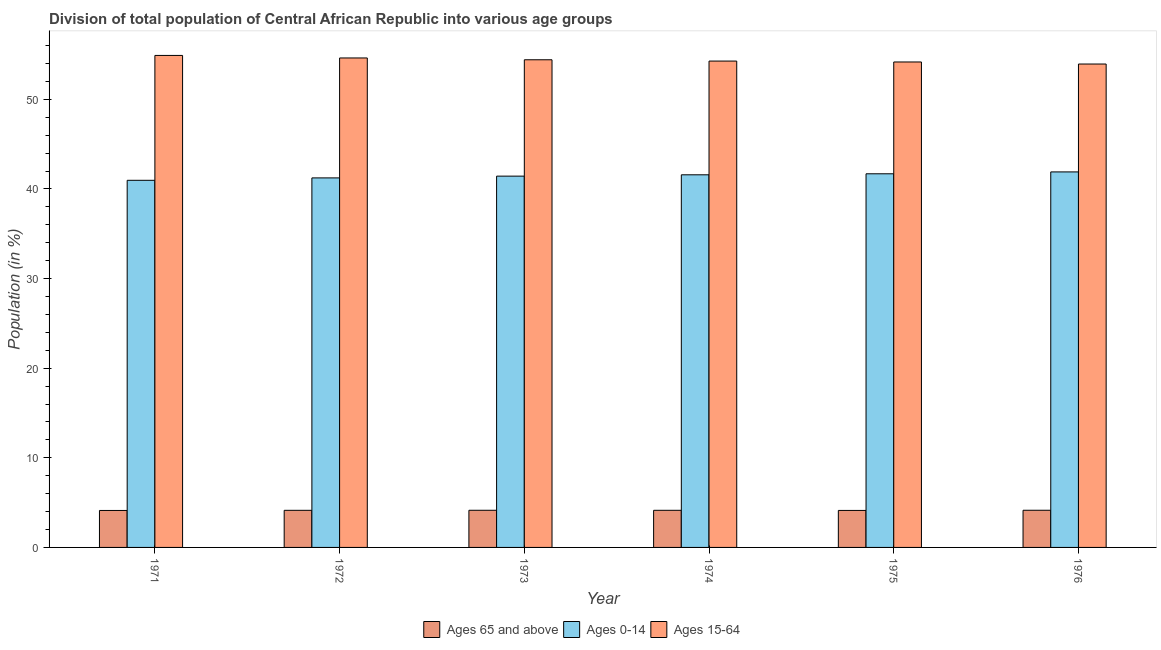How many groups of bars are there?
Offer a terse response. 6. Are the number of bars on each tick of the X-axis equal?
Keep it short and to the point. Yes. In how many cases, is the number of bars for a given year not equal to the number of legend labels?
Keep it short and to the point. 0. What is the percentage of population within the age-group 15-64 in 1975?
Make the answer very short. 54.17. Across all years, what is the maximum percentage of population within the age-group 0-14?
Ensure brevity in your answer.  41.91. Across all years, what is the minimum percentage of population within the age-group 0-14?
Give a very brief answer. 40.97. In which year was the percentage of population within the age-group of 65 and above maximum?
Your response must be concise. 1976. In which year was the percentage of population within the age-group of 65 and above minimum?
Provide a short and direct response. 1971. What is the total percentage of population within the age-group 15-64 in the graph?
Make the answer very short. 326.34. What is the difference between the percentage of population within the age-group 0-14 in 1972 and that in 1976?
Ensure brevity in your answer.  -0.67. What is the difference between the percentage of population within the age-group 15-64 in 1974 and the percentage of population within the age-group 0-14 in 1972?
Provide a succinct answer. -0.35. What is the average percentage of population within the age-group 0-14 per year?
Make the answer very short. 41.47. In how many years, is the percentage of population within the age-group of 65 and above greater than 2 %?
Offer a terse response. 6. What is the ratio of the percentage of population within the age-group 0-14 in 1972 to that in 1973?
Provide a succinct answer. 1. Is the percentage of population within the age-group of 65 and above in 1973 less than that in 1976?
Your answer should be compact. Yes. Is the difference between the percentage of population within the age-group 15-64 in 1972 and 1976 greater than the difference between the percentage of population within the age-group of 65 and above in 1972 and 1976?
Give a very brief answer. No. What is the difference between the highest and the second highest percentage of population within the age-group 15-64?
Ensure brevity in your answer.  0.28. What is the difference between the highest and the lowest percentage of population within the age-group of 65 and above?
Make the answer very short. 0.02. What does the 2nd bar from the left in 1973 represents?
Offer a terse response. Ages 0-14. What does the 3rd bar from the right in 1975 represents?
Your answer should be compact. Ages 65 and above. How many years are there in the graph?
Provide a short and direct response. 6. Are the values on the major ticks of Y-axis written in scientific E-notation?
Offer a terse response. No. Does the graph contain any zero values?
Ensure brevity in your answer.  No. What is the title of the graph?
Provide a short and direct response. Division of total population of Central African Republic into various age groups
. What is the label or title of the X-axis?
Ensure brevity in your answer.  Year. What is the label or title of the Y-axis?
Make the answer very short. Population (in %). What is the Population (in %) of Ages 65 and above in 1971?
Offer a very short reply. 4.12. What is the Population (in %) of Ages 0-14 in 1971?
Offer a terse response. 40.97. What is the Population (in %) in Ages 15-64 in 1971?
Ensure brevity in your answer.  54.91. What is the Population (in %) in Ages 65 and above in 1972?
Offer a terse response. 4.14. What is the Population (in %) of Ages 0-14 in 1972?
Ensure brevity in your answer.  41.24. What is the Population (in %) of Ages 15-64 in 1972?
Provide a succinct answer. 54.62. What is the Population (in %) of Ages 65 and above in 1973?
Offer a very short reply. 4.15. What is the Population (in %) in Ages 0-14 in 1973?
Keep it short and to the point. 41.43. What is the Population (in %) of Ages 15-64 in 1973?
Provide a short and direct response. 54.42. What is the Population (in %) in Ages 65 and above in 1974?
Make the answer very short. 4.14. What is the Population (in %) of Ages 0-14 in 1974?
Provide a succinct answer. 41.58. What is the Population (in %) in Ages 15-64 in 1974?
Your answer should be compact. 54.28. What is the Population (in %) in Ages 65 and above in 1975?
Offer a very short reply. 4.13. What is the Population (in %) of Ages 0-14 in 1975?
Your answer should be compact. 41.7. What is the Population (in %) of Ages 15-64 in 1975?
Keep it short and to the point. 54.17. What is the Population (in %) in Ages 65 and above in 1976?
Provide a short and direct response. 4.15. What is the Population (in %) of Ages 0-14 in 1976?
Provide a short and direct response. 41.91. What is the Population (in %) in Ages 15-64 in 1976?
Give a very brief answer. 53.95. Across all years, what is the maximum Population (in %) in Ages 65 and above?
Offer a terse response. 4.15. Across all years, what is the maximum Population (in %) of Ages 0-14?
Your answer should be very brief. 41.91. Across all years, what is the maximum Population (in %) of Ages 15-64?
Provide a succinct answer. 54.91. Across all years, what is the minimum Population (in %) in Ages 65 and above?
Provide a succinct answer. 4.12. Across all years, what is the minimum Population (in %) in Ages 0-14?
Your answer should be very brief. 40.97. Across all years, what is the minimum Population (in %) in Ages 15-64?
Offer a very short reply. 53.95. What is the total Population (in %) in Ages 65 and above in the graph?
Make the answer very short. 24.83. What is the total Population (in %) in Ages 0-14 in the graph?
Keep it short and to the point. 248.83. What is the total Population (in %) of Ages 15-64 in the graph?
Make the answer very short. 326.34. What is the difference between the Population (in %) of Ages 65 and above in 1971 and that in 1972?
Your answer should be very brief. -0.02. What is the difference between the Population (in %) of Ages 0-14 in 1971 and that in 1972?
Give a very brief answer. -0.27. What is the difference between the Population (in %) in Ages 15-64 in 1971 and that in 1972?
Give a very brief answer. 0.28. What is the difference between the Population (in %) in Ages 65 and above in 1971 and that in 1973?
Provide a succinct answer. -0.02. What is the difference between the Population (in %) in Ages 0-14 in 1971 and that in 1973?
Your response must be concise. -0.46. What is the difference between the Population (in %) of Ages 15-64 in 1971 and that in 1973?
Offer a terse response. 0.49. What is the difference between the Population (in %) in Ages 65 and above in 1971 and that in 1974?
Provide a succinct answer. -0.02. What is the difference between the Population (in %) of Ages 0-14 in 1971 and that in 1974?
Provide a succinct answer. -0.61. What is the difference between the Population (in %) in Ages 15-64 in 1971 and that in 1974?
Provide a succinct answer. 0.63. What is the difference between the Population (in %) of Ages 65 and above in 1971 and that in 1975?
Your answer should be very brief. -0. What is the difference between the Population (in %) of Ages 0-14 in 1971 and that in 1975?
Provide a short and direct response. -0.73. What is the difference between the Population (in %) of Ages 15-64 in 1971 and that in 1975?
Offer a terse response. 0.73. What is the difference between the Population (in %) in Ages 65 and above in 1971 and that in 1976?
Offer a terse response. -0.02. What is the difference between the Population (in %) in Ages 0-14 in 1971 and that in 1976?
Offer a terse response. -0.94. What is the difference between the Population (in %) of Ages 15-64 in 1971 and that in 1976?
Offer a terse response. 0.96. What is the difference between the Population (in %) in Ages 65 and above in 1972 and that in 1973?
Give a very brief answer. -0.01. What is the difference between the Population (in %) in Ages 0-14 in 1972 and that in 1973?
Provide a succinct answer. -0.2. What is the difference between the Population (in %) of Ages 15-64 in 1972 and that in 1973?
Make the answer very short. 0.2. What is the difference between the Population (in %) of Ages 65 and above in 1972 and that in 1974?
Ensure brevity in your answer.  -0. What is the difference between the Population (in %) of Ages 0-14 in 1972 and that in 1974?
Make the answer very short. -0.35. What is the difference between the Population (in %) of Ages 15-64 in 1972 and that in 1974?
Give a very brief answer. 0.35. What is the difference between the Population (in %) in Ages 65 and above in 1972 and that in 1975?
Provide a short and direct response. 0.01. What is the difference between the Population (in %) of Ages 0-14 in 1972 and that in 1975?
Offer a very short reply. -0.46. What is the difference between the Population (in %) of Ages 15-64 in 1972 and that in 1975?
Your answer should be very brief. 0.45. What is the difference between the Population (in %) of Ages 65 and above in 1972 and that in 1976?
Your response must be concise. -0.01. What is the difference between the Population (in %) of Ages 0-14 in 1972 and that in 1976?
Your answer should be compact. -0.67. What is the difference between the Population (in %) of Ages 15-64 in 1972 and that in 1976?
Your answer should be very brief. 0.68. What is the difference between the Population (in %) in Ages 65 and above in 1973 and that in 1974?
Provide a succinct answer. 0. What is the difference between the Population (in %) of Ages 0-14 in 1973 and that in 1974?
Ensure brevity in your answer.  -0.15. What is the difference between the Population (in %) of Ages 15-64 in 1973 and that in 1974?
Keep it short and to the point. 0.14. What is the difference between the Population (in %) in Ages 65 and above in 1973 and that in 1975?
Ensure brevity in your answer.  0.02. What is the difference between the Population (in %) in Ages 0-14 in 1973 and that in 1975?
Keep it short and to the point. -0.26. What is the difference between the Population (in %) of Ages 15-64 in 1973 and that in 1975?
Ensure brevity in your answer.  0.24. What is the difference between the Population (in %) of Ages 65 and above in 1973 and that in 1976?
Provide a succinct answer. -0. What is the difference between the Population (in %) of Ages 0-14 in 1973 and that in 1976?
Offer a very short reply. -0.47. What is the difference between the Population (in %) in Ages 15-64 in 1973 and that in 1976?
Give a very brief answer. 0.47. What is the difference between the Population (in %) in Ages 65 and above in 1974 and that in 1975?
Make the answer very short. 0.01. What is the difference between the Population (in %) in Ages 0-14 in 1974 and that in 1975?
Give a very brief answer. -0.11. What is the difference between the Population (in %) of Ages 15-64 in 1974 and that in 1975?
Your answer should be very brief. 0.1. What is the difference between the Population (in %) of Ages 65 and above in 1974 and that in 1976?
Offer a very short reply. -0.01. What is the difference between the Population (in %) in Ages 0-14 in 1974 and that in 1976?
Keep it short and to the point. -0.32. What is the difference between the Population (in %) in Ages 15-64 in 1974 and that in 1976?
Give a very brief answer. 0.33. What is the difference between the Population (in %) in Ages 65 and above in 1975 and that in 1976?
Your response must be concise. -0.02. What is the difference between the Population (in %) of Ages 0-14 in 1975 and that in 1976?
Make the answer very short. -0.21. What is the difference between the Population (in %) of Ages 15-64 in 1975 and that in 1976?
Offer a terse response. 0.23. What is the difference between the Population (in %) of Ages 65 and above in 1971 and the Population (in %) of Ages 0-14 in 1972?
Your answer should be compact. -37.11. What is the difference between the Population (in %) of Ages 65 and above in 1971 and the Population (in %) of Ages 15-64 in 1972?
Your answer should be very brief. -50.5. What is the difference between the Population (in %) of Ages 0-14 in 1971 and the Population (in %) of Ages 15-64 in 1972?
Ensure brevity in your answer.  -13.65. What is the difference between the Population (in %) in Ages 65 and above in 1971 and the Population (in %) in Ages 0-14 in 1973?
Your response must be concise. -37.31. What is the difference between the Population (in %) in Ages 65 and above in 1971 and the Population (in %) in Ages 15-64 in 1973?
Provide a succinct answer. -50.29. What is the difference between the Population (in %) of Ages 0-14 in 1971 and the Population (in %) of Ages 15-64 in 1973?
Offer a terse response. -13.45. What is the difference between the Population (in %) of Ages 65 and above in 1971 and the Population (in %) of Ages 0-14 in 1974?
Provide a succinct answer. -37.46. What is the difference between the Population (in %) of Ages 65 and above in 1971 and the Population (in %) of Ages 15-64 in 1974?
Keep it short and to the point. -50.15. What is the difference between the Population (in %) in Ages 0-14 in 1971 and the Population (in %) in Ages 15-64 in 1974?
Provide a short and direct response. -13.31. What is the difference between the Population (in %) of Ages 65 and above in 1971 and the Population (in %) of Ages 0-14 in 1975?
Provide a short and direct response. -37.57. What is the difference between the Population (in %) in Ages 65 and above in 1971 and the Population (in %) in Ages 15-64 in 1975?
Your answer should be compact. -50.05. What is the difference between the Population (in %) in Ages 0-14 in 1971 and the Population (in %) in Ages 15-64 in 1975?
Ensure brevity in your answer.  -13.21. What is the difference between the Population (in %) of Ages 65 and above in 1971 and the Population (in %) of Ages 0-14 in 1976?
Offer a very short reply. -37.78. What is the difference between the Population (in %) in Ages 65 and above in 1971 and the Population (in %) in Ages 15-64 in 1976?
Your answer should be very brief. -49.82. What is the difference between the Population (in %) of Ages 0-14 in 1971 and the Population (in %) of Ages 15-64 in 1976?
Provide a succinct answer. -12.98. What is the difference between the Population (in %) in Ages 65 and above in 1972 and the Population (in %) in Ages 0-14 in 1973?
Your answer should be compact. -37.29. What is the difference between the Population (in %) of Ages 65 and above in 1972 and the Population (in %) of Ages 15-64 in 1973?
Keep it short and to the point. -50.28. What is the difference between the Population (in %) of Ages 0-14 in 1972 and the Population (in %) of Ages 15-64 in 1973?
Keep it short and to the point. -13.18. What is the difference between the Population (in %) of Ages 65 and above in 1972 and the Population (in %) of Ages 0-14 in 1974?
Your answer should be compact. -37.44. What is the difference between the Population (in %) in Ages 65 and above in 1972 and the Population (in %) in Ages 15-64 in 1974?
Provide a succinct answer. -50.13. What is the difference between the Population (in %) of Ages 0-14 in 1972 and the Population (in %) of Ages 15-64 in 1974?
Provide a short and direct response. -13.04. What is the difference between the Population (in %) in Ages 65 and above in 1972 and the Population (in %) in Ages 0-14 in 1975?
Your answer should be compact. -37.56. What is the difference between the Population (in %) in Ages 65 and above in 1972 and the Population (in %) in Ages 15-64 in 1975?
Ensure brevity in your answer.  -50.03. What is the difference between the Population (in %) of Ages 0-14 in 1972 and the Population (in %) of Ages 15-64 in 1975?
Provide a short and direct response. -12.94. What is the difference between the Population (in %) in Ages 65 and above in 1972 and the Population (in %) in Ages 0-14 in 1976?
Your response must be concise. -37.77. What is the difference between the Population (in %) in Ages 65 and above in 1972 and the Population (in %) in Ages 15-64 in 1976?
Offer a terse response. -49.81. What is the difference between the Population (in %) of Ages 0-14 in 1972 and the Population (in %) of Ages 15-64 in 1976?
Keep it short and to the point. -12.71. What is the difference between the Population (in %) of Ages 65 and above in 1973 and the Population (in %) of Ages 0-14 in 1974?
Ensure brevity in your answer.  -37.44. What is the difference between the Population (in %) of Ages 65 and above in 1973 and the Population (in %) of Ages 15-64 in 1974?
Your answer should be compact. -50.13. What is the difference between the Population (in %) in Ages 0-14 in 1973 and the Population (in %) in Ages 15-64 in 1974?
Provide a succinct answer. -12.84. What is the difference between the Population (in %) of Ages 65 and above in 1973 and the Population (in %) of Ages 0-14 in 1975?
Your answer should be compact. -37.55. What is the difference between the Population (in %) in Ages 65 and above in 1973 and the Population (in %) in Ages 15-64 in 1975?
Your answer should be very brief. -50.03. What is the difference between the Population (in %) in Ages 0-14 in 1973 and the Population (in %) in Ages 15-64 in 1975?
Keep it short and to the point. -12.74. What is the difference between the Population (in %) in Ages 65 and above in 1973 and the Population (in %) in Ages 0-14 in 1976?
Your answer should be compact. -37.76. What is the difference between the Population (in %) in Ages 65 and above in 1973 and the Population (in %) in Ages 15-64 in 1976?
Ensure brevity in your answer.  -49.8. What is the difference between the Population (in %) in Ages 0-14 in 1973 and the Population (in %) in Ages 15-64 in 1976?
Give a very brief answer. -12.51. What is the difference between the Population (in %) in Ages 65 and above in 1974 and the Population (in %) in Ages 0-14 in 1975?
Make the answer very short. -37.56. What is the difference between the Population (in %) in Ages 65 and above in 1974 and the Population (in %) in Ages 15-64 in 1975?
Provide a succinct answer. -50.03. What is the difference between the Population (in %) in Ages 0-14 in 1974 and the Population (in %) in Ages 15-64 in 1975?
Offer a very short reply. -12.59. What is the difference between the Population (in %) in Ages 65 and above in 1974 and the Population (in %) in Ages 0-14 in 1976?
Ensure brevity in your answer.  -37.76. What is the difference between the Population (in %) of Ages 65 and above in 1974 and the Population (in %) of Ages 15-64 in 1976?
Ensure brevity in your answer.  -49.8. What is the difference between the Population (in %) of Ages 0-14 in 1974 and the Population (in %) of Ages 15-64 in 1976?
Provide a succinct answer. -12.36. What is the difference between the Population (in %) of Ages 65 and above in 1975 and the Population (in %) of Ages 0-14 in 1976?
Provide a short and direct response. -37.78. What is the difference between the Population (in %) in Ages 65 and above in 1975 and the Population (in %) in Ages 15-64 in 1976?
Your answer should be very brief. -49.82. What is the difference between the Population (in %) in Ages 0-14 in 1975 and the Population (in %) in Ages 15-64 in 1976?
Your answer should be very brief. -12.25. What is the average Population (in %) in Ages 65 and above per year?
Provide a succinct answer. 4.14. What is the average Population (in %) in Ages 0-14 per year?
Give a very brief answer. 41.47. What is the average Population (in %) of Ages 15-64 per year?
Provide a succinct answer. 54.39. In the year 1971, what is the difference between the Population (in %) of Ages 65 and above and Population (in %) of Ages 0-14?
Your answer should be compact. -36.84. In the year 1971, what is the difference between the Population (in %) of Ages 65 and above and Population (in %) of Ages 15-64?
Provide a short and direct response. -50.78. In the year 1971, what is the difference between the Population (in %) of Ages 0-14 and Population (in %) of Ages 15-64?
Your response must be concise. -13.94. In the year 1972, what is the difference between the Population (in %) of Ages 65 and above and Population (in %) of Ages 0-14?
Ensure brevity in your answer.  -37.1. In the year 1972, what is the difference between the Population (in %) of Ages 65 and above and Population (in %) of Ages 15-64?
Offer a very short reply. -50.48. In the year 1972, what is the difference between the Population (in %) of Ages 0-14 and Population (in %) of Ages 15-64?
Keep it short and to the point. -13.38. In the year 1973, what is the difference between the Population (in %) of Ages 65 and above and Population (in %) of Ages 0-14?
Keep it short and to the point. -37.29. In the year 1973, what is the difference between the Population (in %) of Ages 65 and above and Population (in %) of Ages 15-64?
Your response must be concise. -50.27. In the year 1973, what is the difference between the Population (in %) in Ages 0-14 and Population (in %) in Ages 15-64?
Offer a very short reply. -12.99. In the year 1974, what is the difference between the Population (in %) in Ages 65 and above and Population (in %) in Ages 0-14?
Provide a succinct answer. -37.44. In the year 1974, what is the difference between the Population (in %) of Ages 65 and above and Population (in %) of Ages 15-64?
Offer a terse response. -50.13. In the year 1974, what is the difference between the Population (in %) of Ages 0-14 and Population (in %) of Ages 15-64?
Your answer should be compact. -12.69. In the year 1975, what is the difference between the Population (in %) of Ages 65 and above and Population (in %) of Ages 0-14?
Keep it short and to the point. -37.57. In the year 1975, what is the difference between the Population (in %) of Ages 65 and above and Population (in %) of Ages 15-64?
Offer a terse response. -50.05. In the year 1975, what is the difference between the Population (in %) in Ages 0-14 and Population (in %) in Ages 15-64?
Give a very brief answer. -12.48. In the year 1976, what is the difference between the Population (in %) in Ages 65 and above and Population (in %) in Ages 0-14?
Give a very brief answer. -37.76. In the year 1976, what is the difference between the Population (in %) in Ages 65 and above and Population (in %) in Ages 15-64?
Make the answer very short. -49.8. In the year 1976, what is the difference between the Population (in %) of Ages 0-14 and Population (in %) of Ages 15-64?
Offer a very short reply. -12.04. What is the ratio of the Population (in %) of Ages 65 and above in 1971 to that in 1972?
Your response must be concise. 1. What is the ratio of the Population (in %) in Ages 0-14 in 1971 to that in 1972?
Provide a short and direct response. 0.99. What is the ratio of the Population (in %) of Ages 65 and above in 1971 to that in 1973?
Provide a short and direct response. 0.99. What is the ratio of the Population (in %) in Ages 15-64 in 1971 to that in 1973?
Offer a terse response. 1.01. What is the ratio of the Population (in %) of Ages 0-14 in 1971 to that in 1974?
Keep it short and to the point. 0.99. What is the ratio of the Population (in %) of Ages 15-64 in 1971 to that in 1974?
Ensure brevity in your answer.  1.01. What is the ratio of the Population (in %) in Ages 65 and above in 1971 to that in 1975?
Your answer should be very brief. 1. What is the ratio of the Population (in %) of Ages 0-14 in 1971 to that in 1975?
Provide a succinct answer. 0.98. What is the ratio of the Population (in %) of Ages 15-64 in 1971 to that in 1975?
Keep it short and to the point. 1.01. What is the ratio of the Population (in %) in Ages 0-14 in 1971 to that in 1976?
Provide a succinct answer. 0.98. What is the ratio of the Population (in %) in Ages 15-64 in 1971 to that in 1976?
Provide a succinct answer. 1.02. What is the ratio of the Population (in %) in Ages 0-14 in 1972 to that in 1973?
Your answer should be very brief. 1. What is the ratio of the Population (in %) of Ages 15-64 in 1972 to that in 1973?
Your answer should be compact. 1. What is the ratio of the Population (in %) of Ages 65 and above in 1972 to that in 1974?
Give a very brief answer. 1. What is the ratio of the Population (in %) in Ages 0-14 in 1972 to that in 1974?
Your answer should be very brief. 0.99. What is the ratio of the Population (in %) in Ages 15-64 in 1972 to that in 1974?
Make the answer very short. 1.01. What is the ratio of the Population (in %) of Ages 65 and above in 1972 to that in 1975?
Provide a short and direct response. 1. What is the ratio of the Population (in %) of Ages 15-64 in 1972 to that in 1975?
Your response must be concise. 1.01. What is the ratio of the Population (in %) of Ages 15-64 in 1972 to that in 1976?
Keep it short and to the point. 1.01. What is the ratio of the Population (in %) in Ages 0-14 in 1973 to that in 1974?
Your answer should be compact. 1. What is the ratio of the Population (in %) of Ages 65 and above in 1973 to that in 1975?
Provide a succinct answer. 1. What is the ratio of the Population (in %) in Ages 15-64 in 1973 to that in 1975?
Ensure brevity in your answer.  1. What is the ratio of the Population (in %) in Ages 65 and above in 1973 to that in 1976?
Provide a succinct answer. 1. What is the ratio of the Population (in %) of Ages 0-14 in 1973 to that in 1976?
Give a very brief answer. 0.99. What is the ratio of the Population (in %) of Ages 15-64 in 1973 to that in 1976?
Ensure brevity in your answer.  1.01. What is the ratio of the Population (in %) of Ages 0-14 in 1974 to that in 1975?
Provide a short and direct response. 1. What is the ratio of the Population (in %) of Ages 65 and above in 1974 to that in 1976?
Give a very brief answer. 1. What is the ratio of the Population (in %) of Ages 0-14 in 1974 to that in 1976?
Make the answer very short. 0.99. What is the ratio of the Population (in %) in Ages 15-64 in 1974 to that in 1976?
Your response must be concise. 1.01. What is the ratio of the Population (in %) of Ages 0-14 in 1975 to that in 1976?
Provide a succinct answer. 0.99. What is the ratio of the Population (in %) in Ages 15-64 in 1975 to that in 1976?
Provide a short and direct response. 1. What is the difference between the highest and the second highest Population (in %) in Ages 65 and above?
Provide a succinct answer. 0. What is the difference between the highest and the second highest Population (in %) of Ages 0-14?
Ensure brevity in your answer.  0.21. What is the difference between the highest and the second highest Population (in %) in Ages 15-64?
Ensure brevity in your answer.  0.28. What is the difference between the highest and the lowest Population (in %) in Ages 65 and above?
Offer a very short reply. 0.02. What is the difference between the highest and the lowest Population (in %) in Ages 0-14?
Your response must be concise. 0.94. What is the difference between the highest and the lowest Population (in %) in Ages 15-64?
Offer a very short reply. 0.96. 